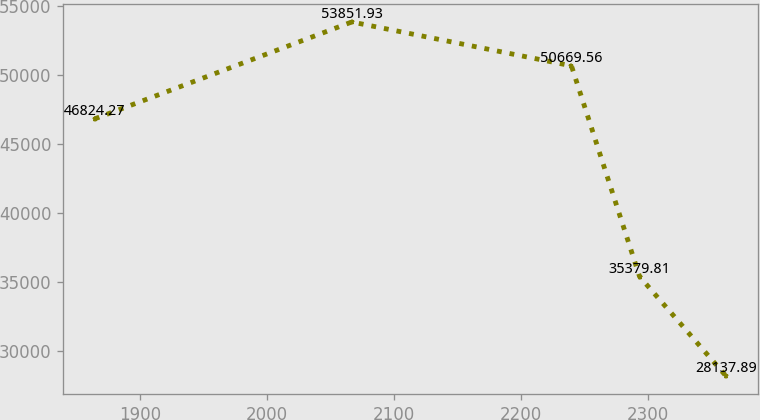Convert chart. <chart><loc_0><loc_0><loc_500><loc_500><line_chart><ecel><fcel>Unnamed: 1<nl><fcel>1864.15<fcel>46824.3<nl><fcel>2066.55<fcel>53851.9<nl><fcel>2239.55<fcel>50669.6<nl><fcel>2293.21<fcel>35379.8<nl><fcel>2361.49<fcel>28137.9<nl></chart> 